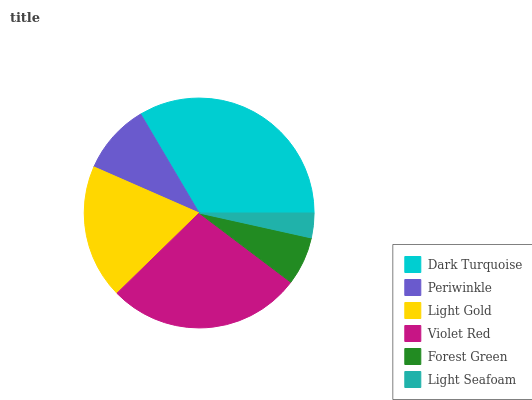Is Light Seafoam the minimum?
Answer yes or no. Yes. Is Dark Turquoise the maximum?
Answer yes or no. Yes. Is Periwinkle the minimum?
Answer yes or no. No. Is Periwinkle the maximum?
Answer yes or no. No. Is Dark Turquoise greater than Periwinkle?
Answer yes or no. Yes. Is Periwinkle less than Dark Turquoise?
Answer yes or no. Yes. Is Periwinkle greater than Dark Turquoise?
Answer yes or no. No. Is Dark Turquoise less than Periwinkle?
Answer yes or no. No. Is Light Gold the high median?
Answer yes or no. Yes. Is Periwinkle the low median?
Answer yes or no. Yes. Is Periwinkle the high median?
Answer yes or no. No. Is Dark Turquoise the low median?
Answer yes or no. No. 